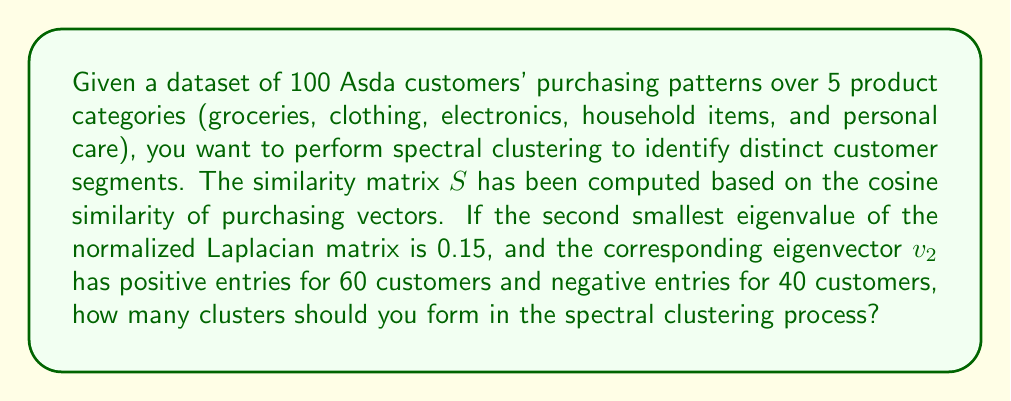What is the answer to this math problem? 1. Recall that spectral clustering uses the eigenvectors of the normalized Laplacian matrix to perform dimensionality reduction before clustering.

2. The number of clusters is typically determined by the eigengap heuristic, which looks at the differences between consecutive eigenvalues.

3. However, in this case, we're given information about the second smallest eigenvalue (λ₂ = 0.15) and its corresponding eigenvector (v₂).

4. The second smallest eigenvalue (λ₂) is also known as the algebraic connectivity of the graph. A small value (close to 0) indicates that the graph can be easily partitioned into two clusters.

5. The sign of the entries in the corresponding eigenvector (v₂) can be used to directly partition the data into two clusters.

6. In this case, v₂ has positive entries for 60 customers and negative entries for 40 customers, naturally suggesting a partition into two clusters.

7. This partition aligns with the relatively small value of λ₂ (0.15), which is close to 0, further supporting the two-cluster solution.

8. Therefore, based on the given information about λ₂ and v₂, the spectral clustering process should form 2 clusters of Asda customers based on their purchasing patterns.
Answer: 2 clusters 